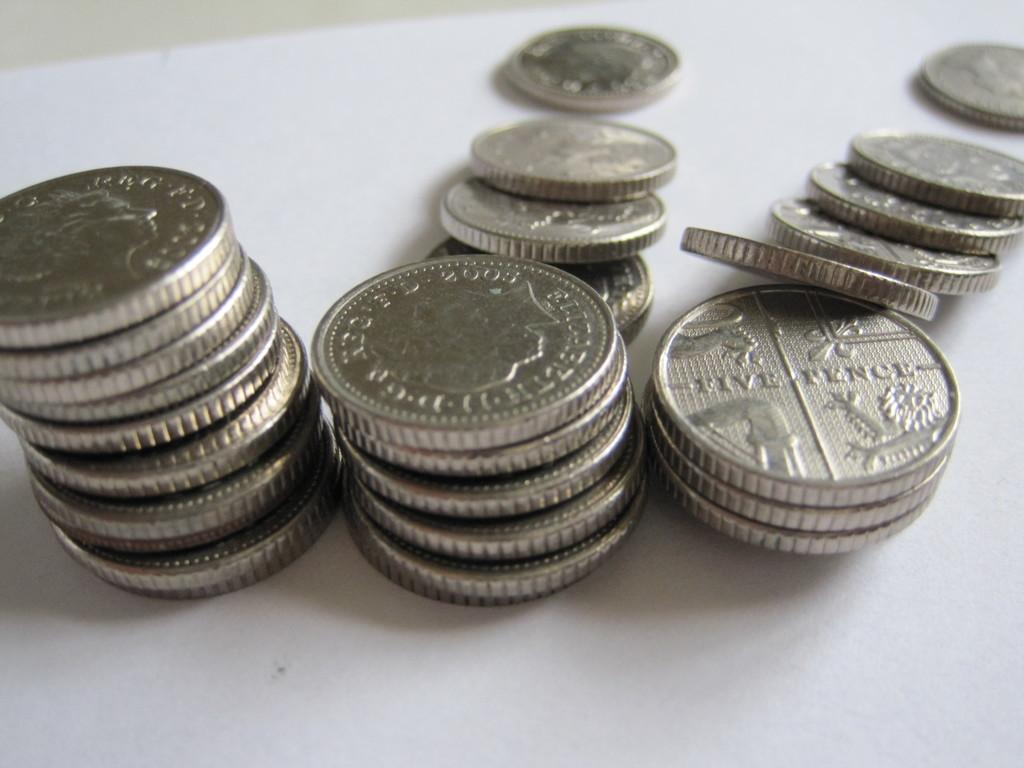<image>
Offer a succinct explanation of the picture presented. many coins and one that says five fence on it 